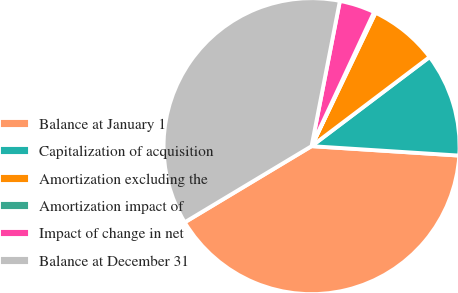Convert chart to OTSL. <chart><loc_0><loc_0><loc_500><loc_500><pie_chart><fcel>Balance at January 1<fcel>Capitalization of acquisition<fcel>Amortization excluding the<fcel>Amortization impact of<fcel>Impact of change in net<fcel>Balance at December 31<nl><fcel>40.38%<fcel>11.31%<fcel>7.59%<fcel>0.17%<fcel>3.88%<fcel>36.67%<nl></chart> 